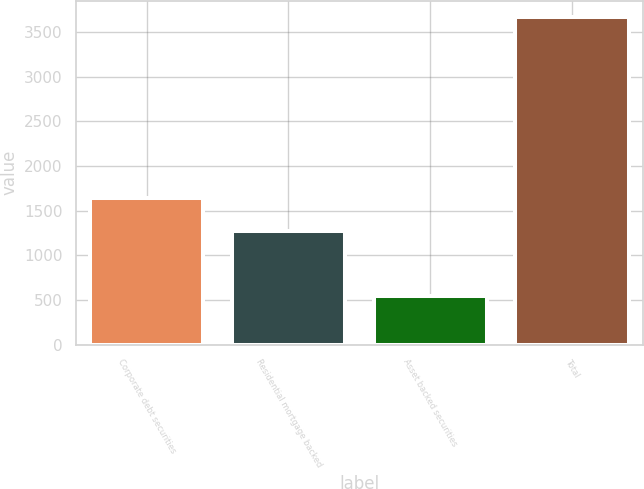Convert chart. <chart><loc_0><loc_0><loc_500><loc_500><bar_chart><fcel>Corporate debt securities<fcel>Residential mortgage backed<fcel>Asset backed securities<fcel>Total<nl><fcel>1647<fcel>1269<fcel>543<fcel>3669<nl></chart> 